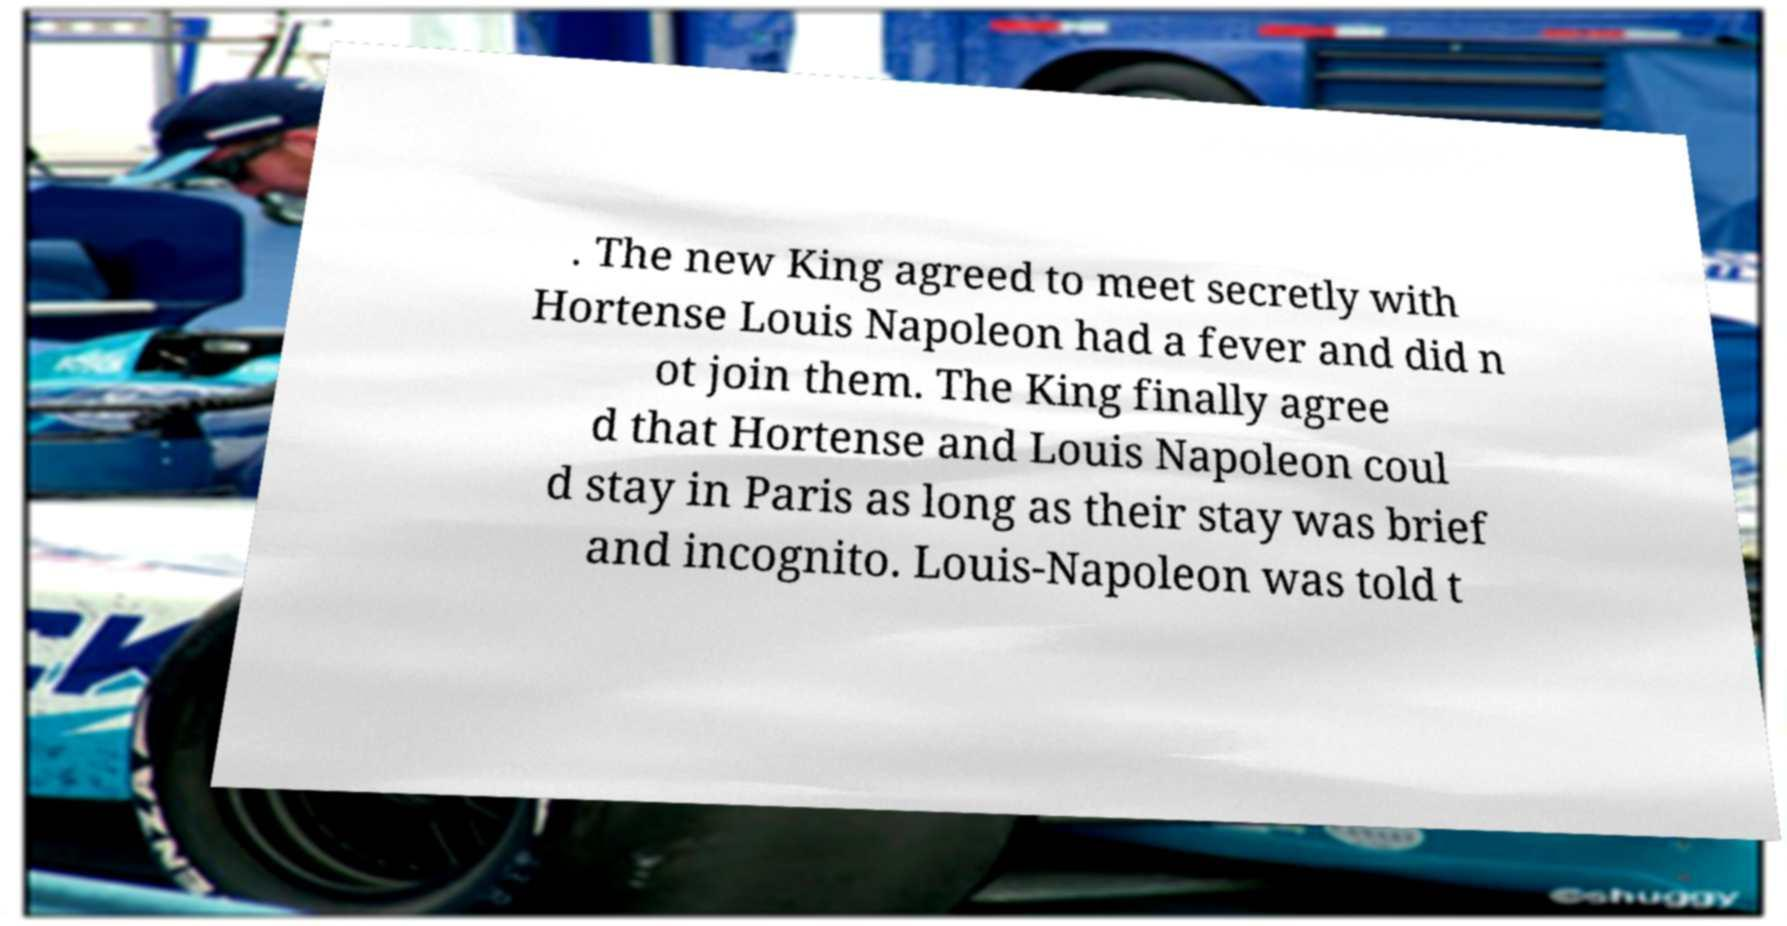Can you read and provide the text displayed in the image?This photo seems to have some interesting text. Can you extract and type it out for me? . The new King agreed to meet secretly with Hortense Louis Napoleon had a fever and did n ot join them. The King finally agree d that Hortense and Louis Napoleon coul d stay in Paris as long as their stay was brief and incognito. Louis-Napoleon was told t 